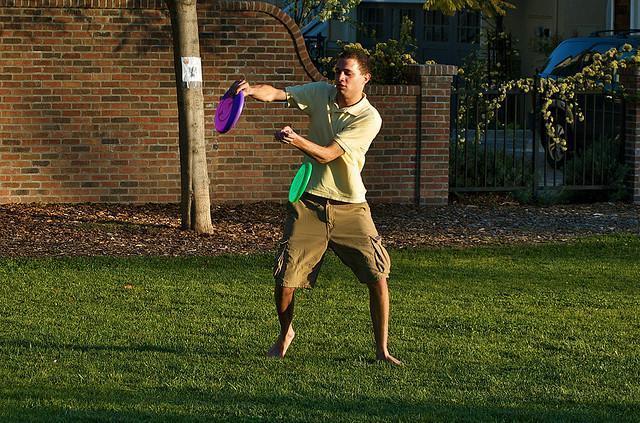How many people do you see?
Give a very brief answer. 1. How many players are there?
Give a very brief answer. 1. 